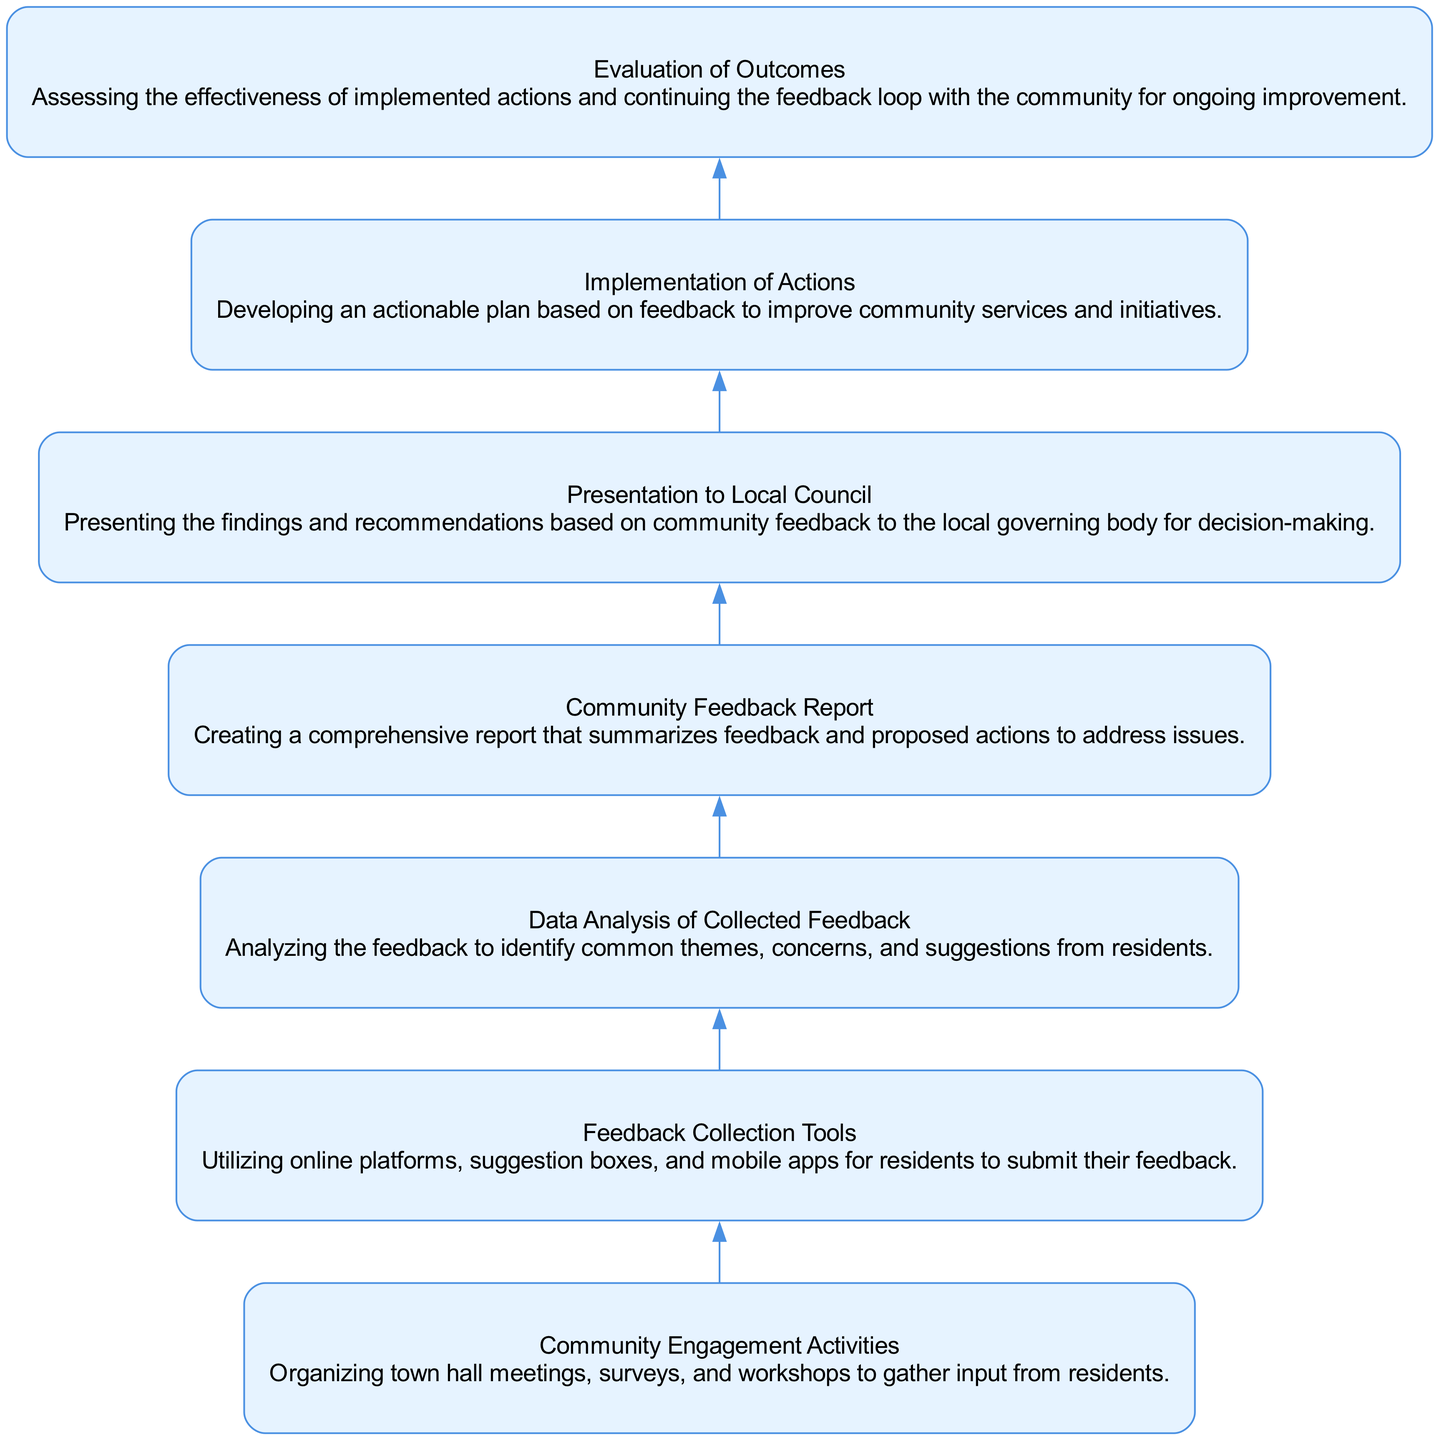What's the first step in the community feedback collection process? The diagram starts at the "Community Engagement Activities" node, which indicates that the first step is to organize activities that gather input from residents.
Answer: Community Engagement Activities How many nodes are present in the diagram? By counting all the distinct steps in the flow, there are a total of 7 nodes, each representing a different stage in the feedback process.
Answer: 7 What type of tools are used for feedback collection? The "Feedback Collection Tools" node specifies online platforms, suggestion boxes, and mobile apps as the tools utilized for gathering feedback from residents.
Answer: Online platforms, suggestion boxes, and mobile apps Which step occurs immediately after data analysis? Looking at the flow from "Data Analysis of Collected Feedback," the next step indicated is the creation of the "Community Feedback Report." This shows the direct progression after analyzing data.
Answer: Community Feedback Report What is the final step in the community feedback collection process? Tracing the flow from the last step, the final node in the diagram is "Evaluation of Outcomes," which assesses the effectiveness of the actions taken based on community feedback.
Answer: Evaluation of Outcomes How many edges connect the nodes in this diagram? Counting the directed connections, there are 6 edges that connect the nodes sequentially, representing the flow from one step to the next in the process.
Answer: 6 What is created after the data analysis phase? The process indicates that after analyzing the feedback, a "Community Feedback Report" is created to summarize the findings and proposed actions.
Answer: Community Feedback Report What action follows the presentation to the local council? The flow chart indicates that after presenting the findings, the next action is the "Implementation of Actions," where proposed changes based on feedback are planned.
Answer: Implementation of Actions What type of feedback is assessed in the last step? The last step, "Evaluation of Outcomes," focuses on assessing the effectiveness of actions that were implemented based on the community feedback collected earlier in the process.
Answer: Effectiveness of actions 